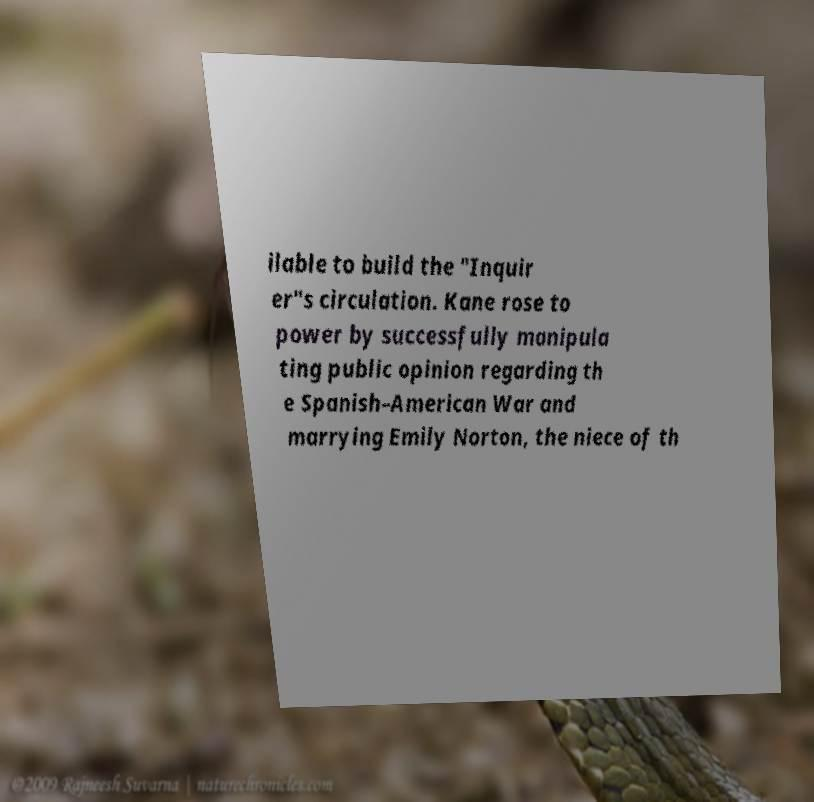What messages or text are displayed in this image? I need them in a readable, typed format. ilable to build the "Inquir er"s circulation. Kane rose to power by successfully manipula ting public opinion regarding th e Spanish–American War and marrying Emily Norton, the niece of th 